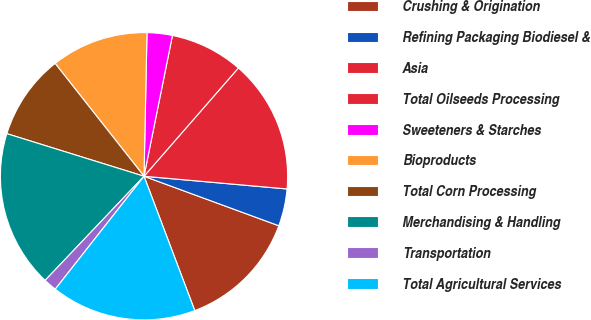Convert chart to OTSL. <chart><loc_0><loc_0><loc_500><loc_500><pie_chart><fcel>Crushing & Origination<fcel>Refining Packaging Biodiesel &<fcel>Asia<fcel>Total Oilseeds Processing<fcel>Sweeteners & Starches<fcel>Bioproducts<fcel>Total Corn Processing<fcel>Merchandising & Handling<fcel>Transportation<fcel>Total Agricultural Services<nl><fcel>13.65%<fcel>4.19%<fcel>15.0%<fcel>8.24%<fcel>2.84%<fcel>10.95%<fcel>9.59%<fcel>17.7%<fcel>1.49%<fcel>16.35%<nl></chart> 